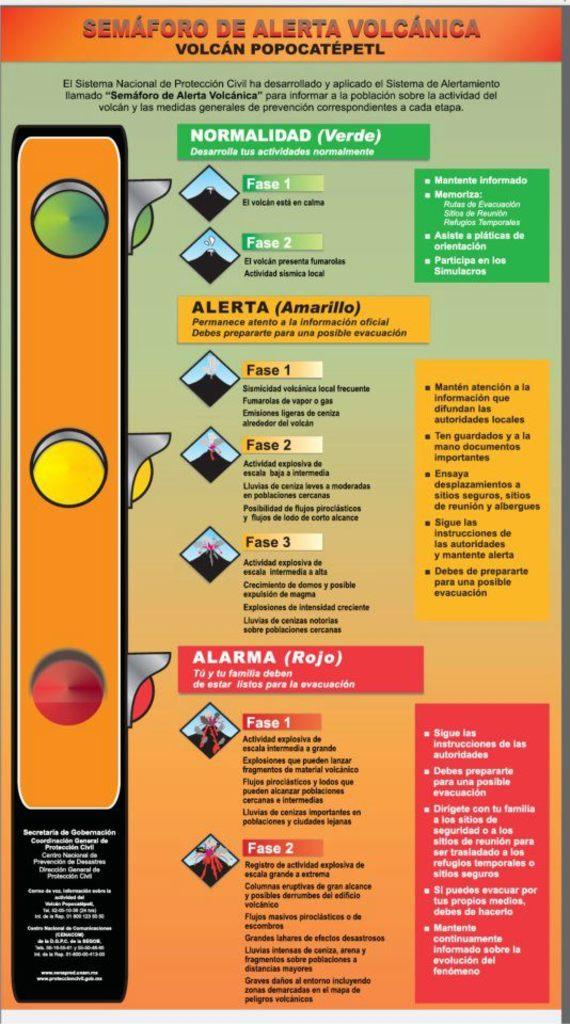<image>
Render a clear and concise summary of the photo. Instructions for a homemade volcano are displayed on this flyer. 